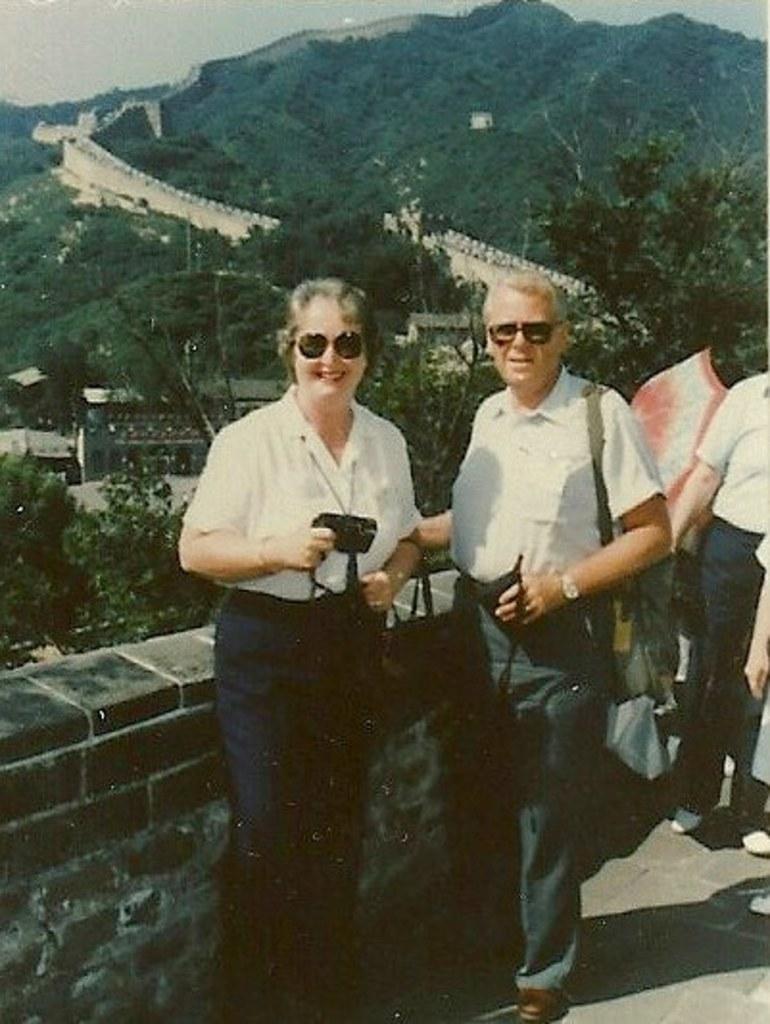Could you give a brief overview of what you see in this image? In this image a woman and a person are standing on the floor before a wall. Beside them there are few persons standing on the floor. Person is carrying a bag and woman is holding a camera in his hand. Behind the wall there are few trees on the hill. There is wall on the hill. 